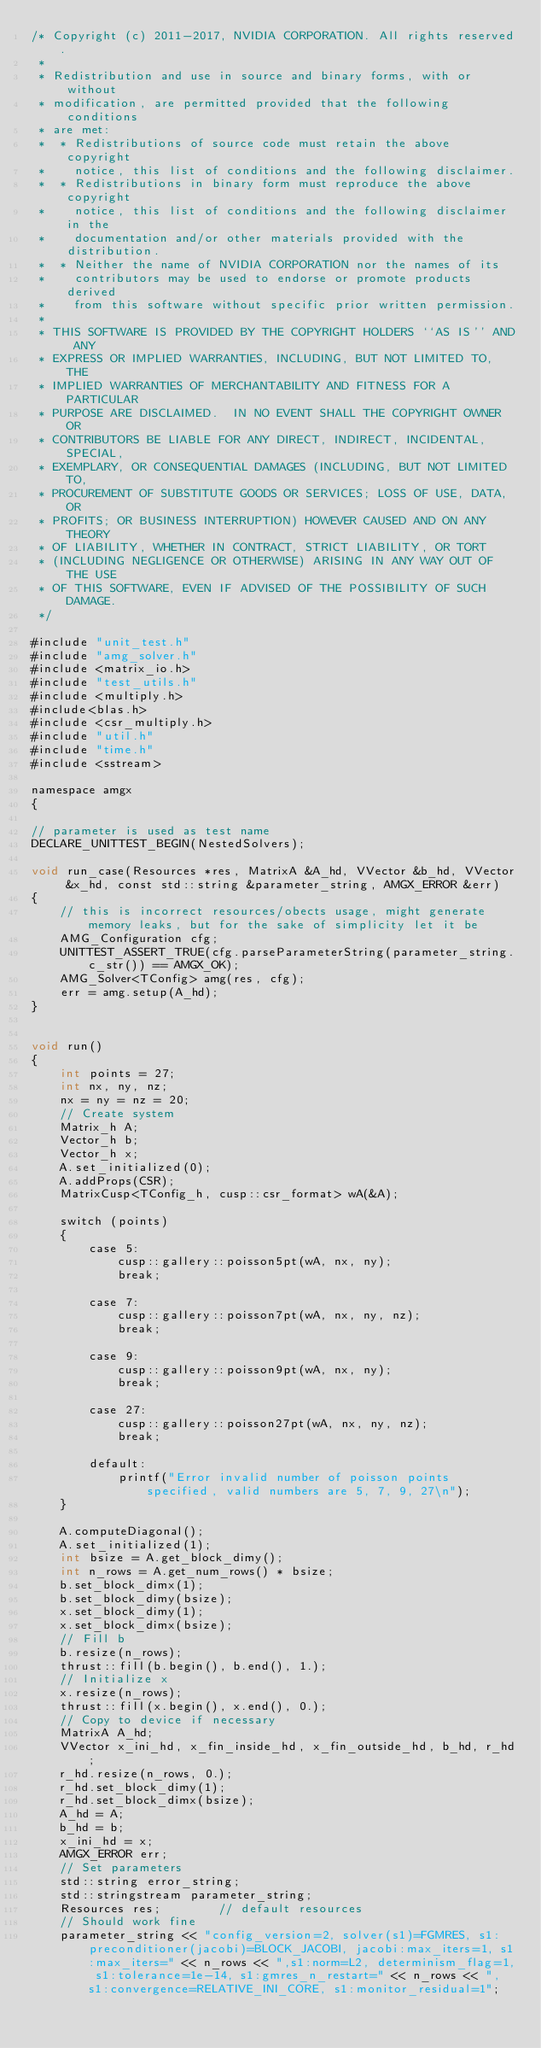<code> <loc_0><loc_0><loc_500><loc_500><_Cuda_>/* Copyright (c) 2011-2017, NVIDIA CORPORATION. All rights reserved.
 *
 * Redistribution and use in source and binary forms, with or without
 * modification, are permitted provided that the following conditions
 * are met:
 *  * Redistributions of source code must retain the above copyright
 *    notice, this list of conditions and the following disclaimer.
 *  * Redistributions in binary form must reproduce the above copyright
 *    notice, this list of conditions and the following disclaimer in the
 *    documentation and/or other materials provided with the distribution.
 *  * Neither the name of NVIDIA CORPORATION nor the names of its
 *    contributors may be used to endorse or promote products derived
 *    from this software without specific prior written permission.
 *
 * THIS SOFTWARE IS PROVIDED BY THE COPYRIGHT HOLDERS ``AS IS'' AND ANY
 * EXPRESS OR IMPLIED WARRANTIES, INCLUDING, BUT NOT LIMITED TO, THE
 * IMPLIED WARRANTIES OF MERCHANTABILITY AND FITNESS FOR A PARTICULAR
 * PURPOSE ARE DISCLAIMED.  IN NO EVENT SHALL THE COPYRIGHT OWNER OR
 * CONTRIBUTORS BE LIABLE FOR ANY DIRECT, INDIRECT, INCIDENTAL, SPECIAL,
 * EXEMPLARY, OR CONSEQUENTIAL DAMAGES (INCLUDING, BUT NOT LIMITED TO,
 * PROCUREMENT OF SUBSTITUTE GOODS OR SERVICES; LOSS OF USE, DATA, OR
 * PROFITS; OR BUSINESS INTERRUPTION) HOWEVER CAUSED AND ON ANY THEORY
 * OF LIABILITY, WHETHER IN CONTRACT, STRICT LIABILITY, OR TORT
 * (INCLUDING NEGLIGENCE OR OTHERWISE) ARISING IN ANY WAY OUT OF THE USE
 * OF THIS SOFTWARE, EVEN IF ADVISED OF THE POSSIBILITY OF SUCH DAMAGE.
 */

#include "unit_test.h"
#include "amg_solver.h"
#include <matrix_io.h>
#include "test_utils.h"
#include <multiply.h>
#include<blas.h>
#include <csr_multiply.h>
#include "util.h"
#include "time.h"
#include <sstream>

namespace amgx
{

// parameter is used as test name
DECLARE_UNITTEST_BEGIN(NestedSolvers);

void run_case(Resources *res, MatrixA &A_hd, VVector &b_hd, VVector &x_hd, const std::string &parameter_string, AMGX_ERROR &err)
{
    // this is incorrect resources/obects usage, might generate memory leaks, but for the sake of simplicity let it be
    AMG_Configuration cfg;
    UNITTEST_ASSERT_TRUE(cfg.parseParameterString(parameter_string.c_str()) == AMGX_OK);
    AMG_Solver<TConfig> amg(res, cfg);
    err = amg.setup(A_hd);
}


void run()
{
    int points = 27;
    int nx, ny, nz;
    nx = ny = nz = 20;
    // Create system
    Matrix_h A;
    Vector_h b;
    Vector_h x;
    A.set_initialized(0);
    A.addProps(CSR);
    MatrixCusp<TConfig_h, cusp::csr_format> wA(&A);

    switch (points)
    {
        case 5:
            cusp::gallery::poisson5pt(wA, nx, ny);
            break;

        case 7:
            cusp::gallery::poisson7pt(wA, nx, ny, nz);
            break;

        case 9:
            cusp::gallery::poisson9pt(wA, nx, ny);
            break;

        case 27:
            cusp::gallery::poisson27pt(wA, nx, ny, nz);
            break;

        default:
            printf("Error invalid number of poisson points specified, valid numbers are 5, 7, 9, 27\n");
    }

    A.computeDiagonal();
    A.set_initialized(1);
    int bsize = A.get_block_dimy();
    int n_rows = A.get_num_rows() * bsize;
    b.set_block_dimx(1);
    b.set_block_dimy(bsize);
    x.set_block_dimy(1);
    x.set_block_dimx(bsize);
    // Fill b
    b.resize(n_rows);
    thrust::fill(b.begin(), b.end(), 1.);
    // Initialize x
    x.resize(n_rows);
    thrust::fill(x.begin(), x.end(), 0.);
    // Copy to device if necessary
    MatrixA A_hd;
    VVector x_ini_hd, x_fin_inside_hd, x_fin_outside_hd, b_hd, r_hd;
    r_hd.resize(n_rows, 0.);
    r_hd.set_block_dimy(1);
    r_hd.set_block_dimx(bsize);
    A_hd = A;
    b_hd = b;
    x_ini_hd = x;
    AMGX_ERROR err;
    // Set parameters
    std::string error_string;
    std::stringstream parameter_string;
    Resources res;        // default resources
    // Should work fine
    parameter_string << "config_version=2, solver(s1)=FGMRES, s1:preconditioner(jacobi)=BLOCK_JACOBI, jacobi:max_iters=1, s1:max_iters=" << n_rows << ",s1:norm=L2, determinism_flag=1, s1:tolerance=1e-14, s1:gmres_n_restart=" << n_rows << ", s1:convergence=RELATIVE_INI_CORE, s1:monitor_residual=1";</code> 